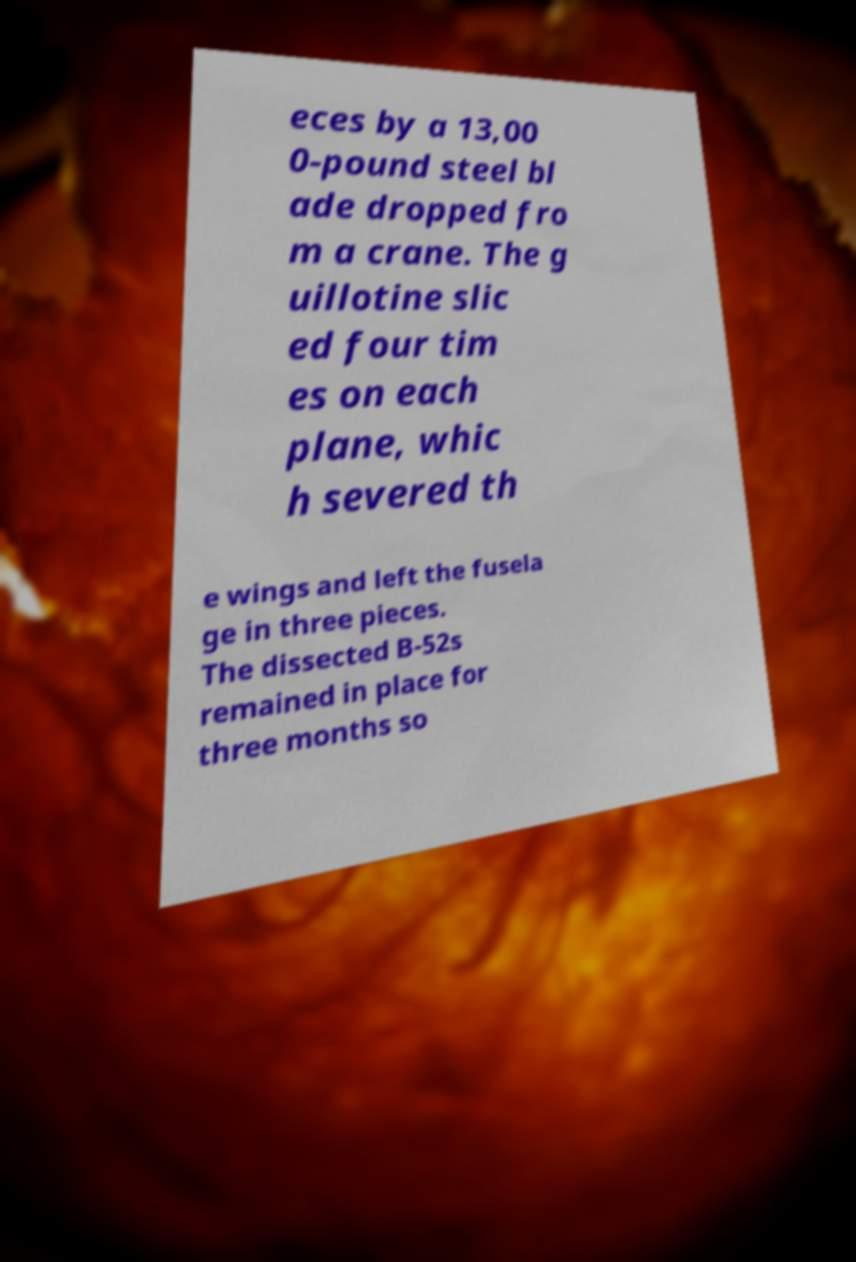Can you read and provide the text displayed in the image?This photo seems to have some interesting text. Can you extract and type it out for me? eces by a 13,00 0-pound steel bl ade dropped fro m a crane. The g uillotine slic ed four tim es on each plane, whic h severed th e wings and left the fusela ge in three pieces. The dissected B-52s remained in place for three months so 